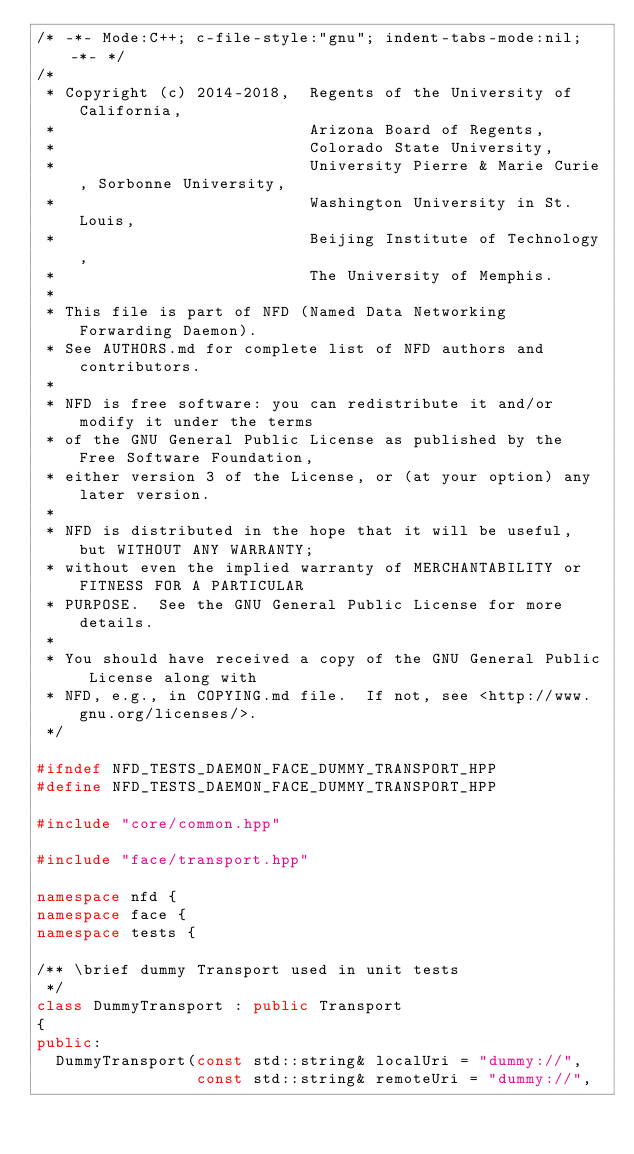Convert code to text. <code><loc_0><loc_0><loc_500><loc_500><_C++_>/* -*- Mode:C++; c-file-style:"gnu"; indent-tabs-mode:nil; -*- */
/*
 * Copyright (c) 2014-2018,  Regents of the University of California,
 *                           Arizona Board of Regents,
 *                           Colorado State University,
 *                           University Pierre & Marie Curie, Sorbonne University,
 *                           Washington University in St. Louis,
 *                           Beijing Institute of Technology,
 *                           The University of Memphis.
 *
 * This file is part of NFD (Named Data Networking Forwarding Daemon).
 * See AUTHORS.md for complete list of NFD authors and contributors.
 *
 * NFD is free software: you can redistribute it and/or modify it under the terms
 * of the GNU General Public License as published by the Free Software Foundation,
 * either version 3 of the License, or (at your option) any later version.
 *
 * NFD is distributed in the hope that it will be useful, but WITHOUT ANY WARRANTY;
 * without even the implied warranty of MERCHANTABILITY or FITNESS FOR A PARTICULAR
 * PURPOSE.  See the GNU General Public License for more details.
 *
 * You should have received a copy of the GNU General Public License along with
 * NFD, e.g., in COPYING.md file.  If not, see <http://www.gnu.org/licenses/>.
 */

#ifndef NFD_TESTS_DAEMON_FACE_DUMMY_TRANSPORT_HPP
#define NFD_TESTS_DAEMON_FACE_DUMMY_TRANSPORT_HPP

#include "core/common.hpp"

#include "face/transport.hpp"

namespace nfd {
namespace face {
namespace tests {

/** \brief dummy Transport used in unit tests
 */
class DummyTransport : public Transport
{
public:
  DummyTransport(const std::string& localUri = "dummy://",
                 const std::string& remoteUri = "dummy://",</code> 